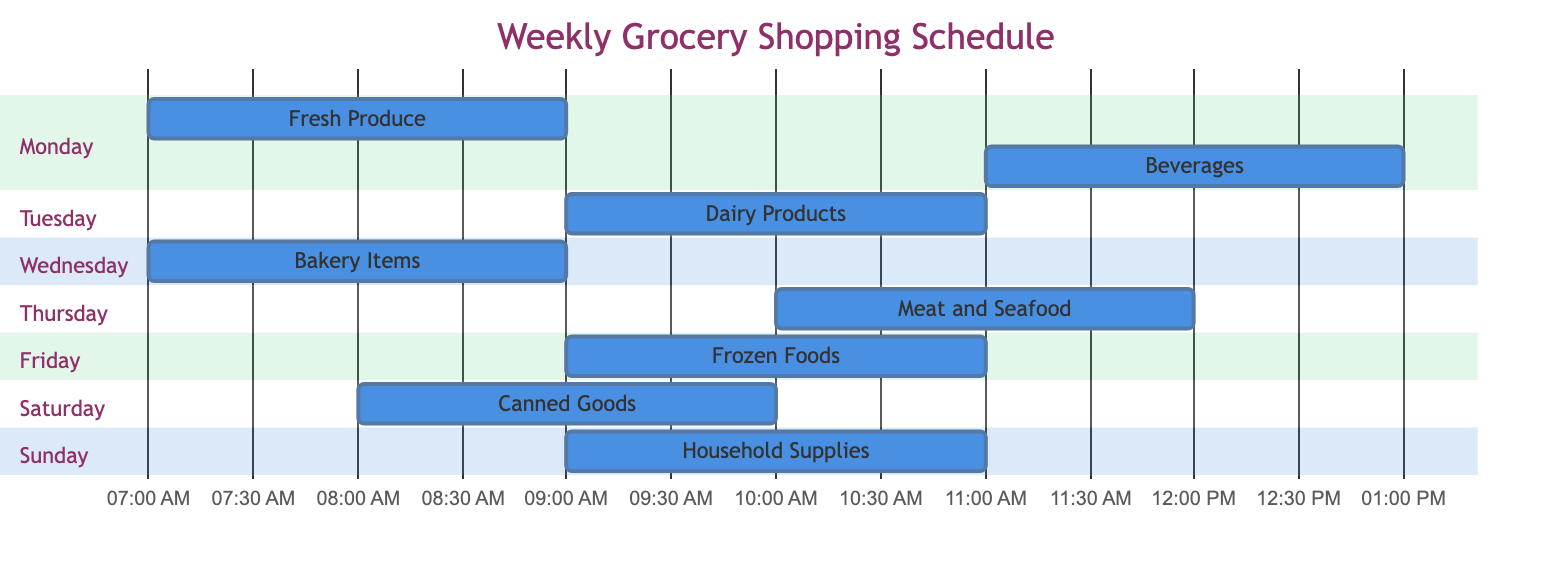What sections are planned for Monday? The Gantt chart shows two tasks scheduled for Monday: Fresh Produce and Beverages. Both tasks are visible in the Monday section, one starting at 08:00 AM and the other at 11:00 AM.
Answer: Fresh Produce, Beverages How long do the Dairy Products take to shop? Looking at the Dairy Products task in the Tuesday section, it starts at 09:00 AM and ends at 11:00 AM, making the duration 2 hours, as indicated on the Gantt chart.
Answer: 2 hours On which day is Bakery Items scheduled? By examining the diagram, Bakery Items appears in the Wednesday section, clearly showing that this task takes place on that day.
Answer: Wednesday What is the earliest time to start shopping for Canned Goods? The Gantt chart shows that shopping for Canned Goods starts at 08:00 AM on Saturday, which is the earliest listed starting time for any section.
Answer: 08:00 AM Which section is scheduled right after Fresh Produce? Fresh Produce ends at 10:00 AM, and the next section to start on Monday is Beverages, which begins at 11:00 AM. Therefore, Beverages is scheduled right after Fresh Produce.
Answer: Beverages How many total tasks are scheduled from Monday to Sunday? Counting the tasks listed in the Gantt chart, there are a total of 8 sections (one for each day from Monday to Sunday), with one task assigned per day, resulting in a total of 8 tasks.
Answer: 8 tasks Which task has the latest start time during the week? By reviewing each section, the task with the latest start time is Meat and Seafood, which begins on Thursday at 10:00 AM. Comparing this to the other start times, no other task starts later.
Answer: Meat and Seafood Between which two tasks is there a gap in shopping time? After analyzing the schedule, there is a gap between Beverages (ending at 01:00 PM on Monday) and Dairy Products (starting at 09:00 AM on Tuesday). This is the first significant gap between two tasks within the chart.
Answer: Beverages and Dairy Products 